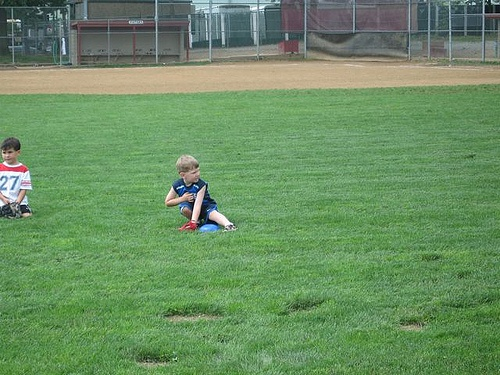Describe the objects in this image and their specific colors. I can see people in darkgreen, darkgray, lightgray, gray, and black tones, people in darkgreen, lavender, gray, darkgray, and black tones, baseball glove in darkgreen, gray, black, darkgray, and purple tones, and baseball glove in darkgreen, brown, salmon, maroon, and gray tones in this image. 